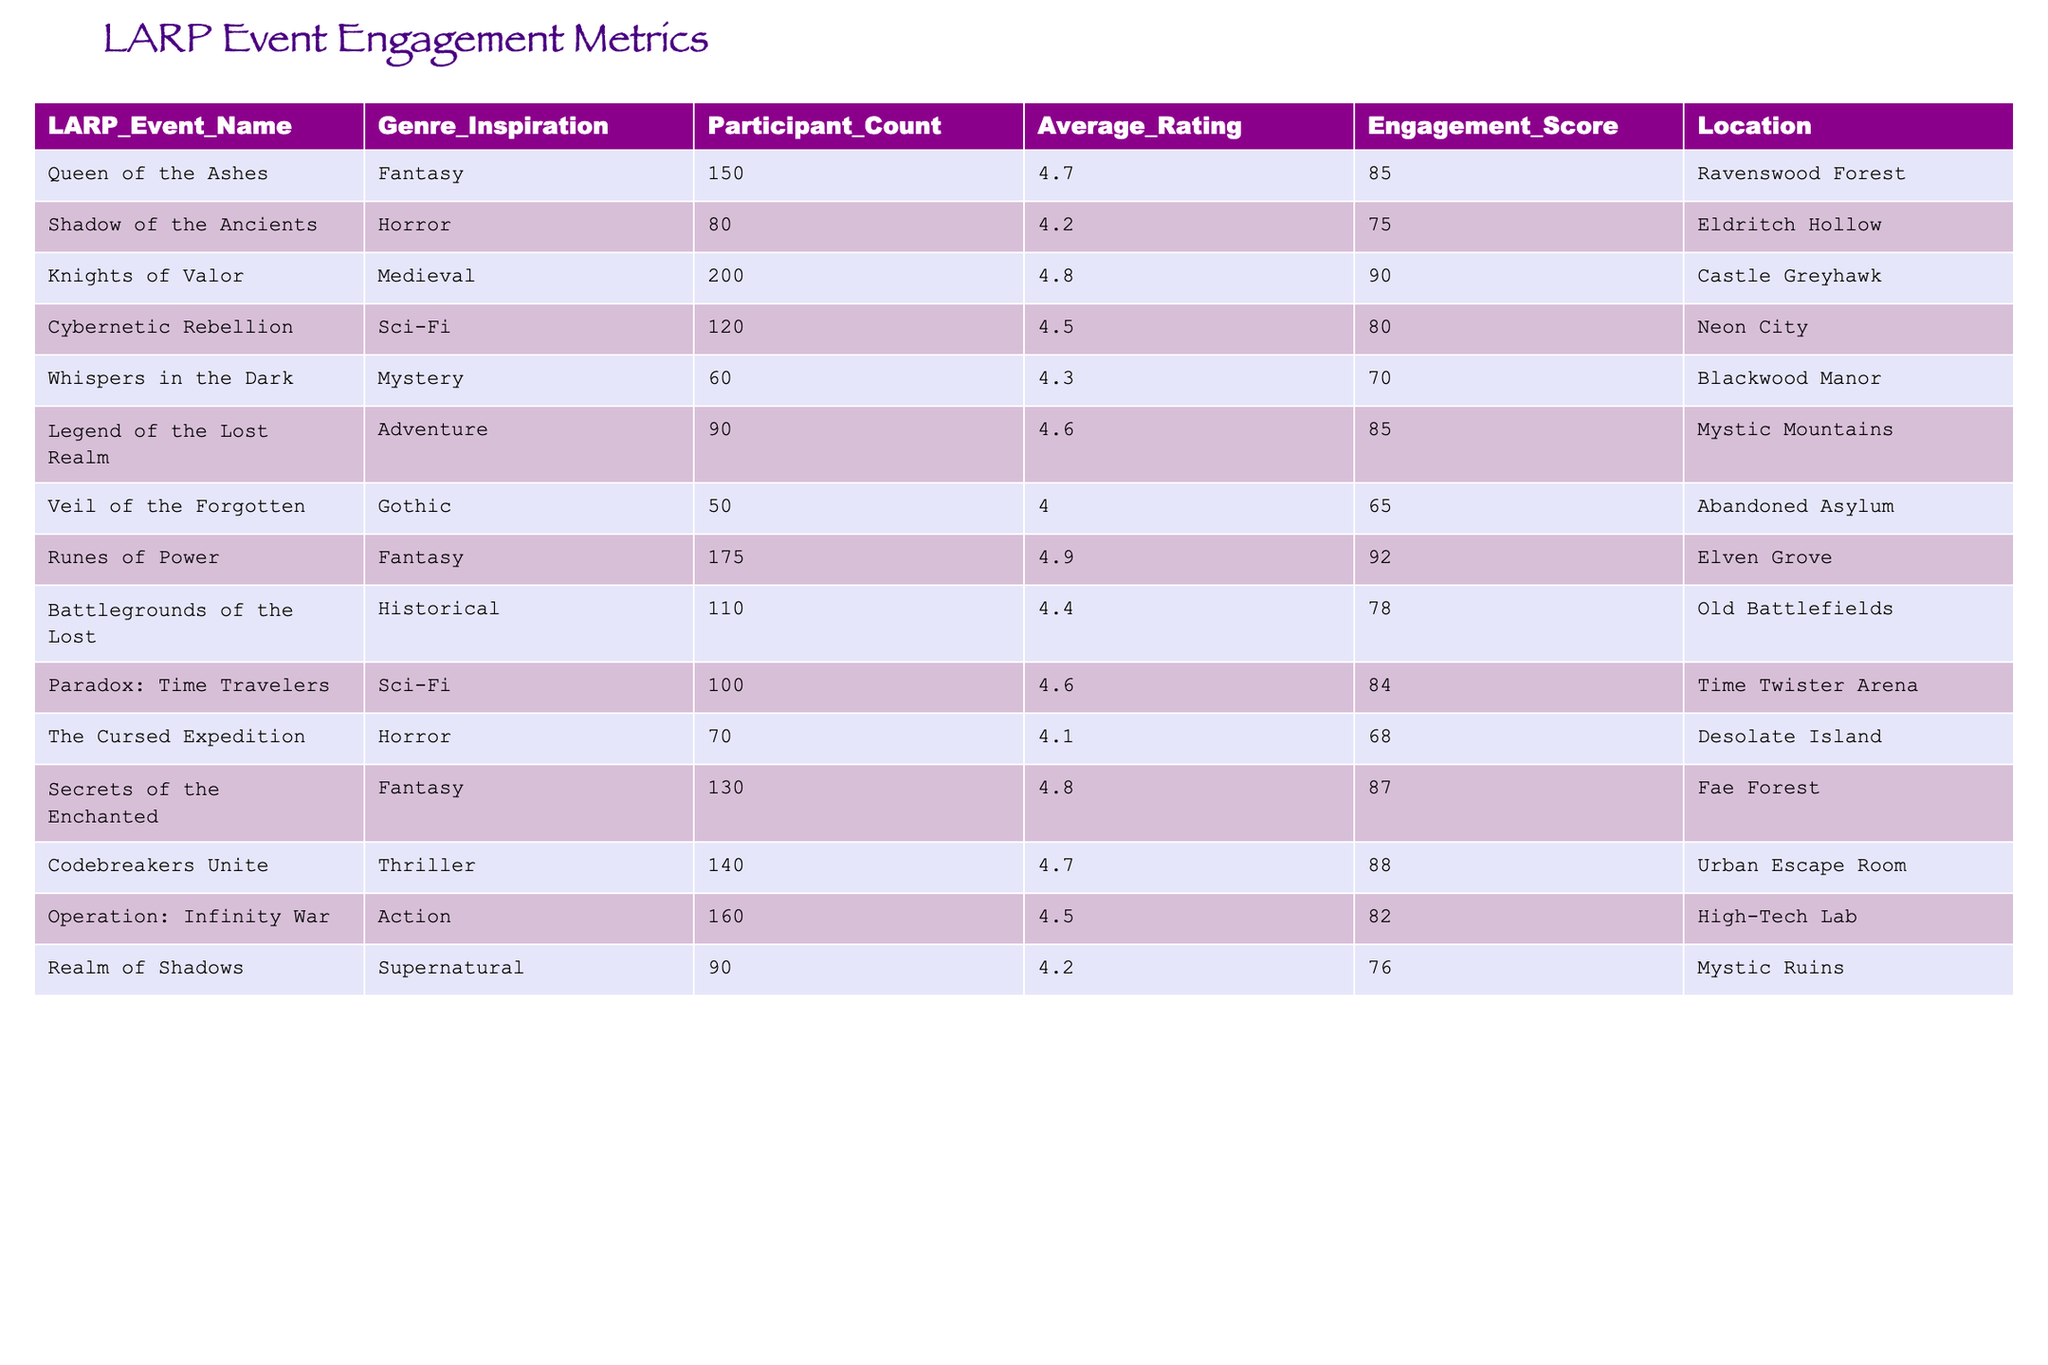What is the engagement score for the "Knights of Valor" event? The engagement score for "Knights of Valor" is listed directly in the table under the corresponding column, which shows a score of 90.
Answer: 90 What is the average participant count for the Fantasy genre events? The participant counts for the Fantasy events are 150, 175, and 130. To find the average, sum these values: 150 + 175 + 130 = 455. Then, divide by the number of events (3), which results in 455/3 = approximately 151.67.
Answer: 151.67 Which event has the highest average rating and what is that rating? Looking through the "Average_Rating" column, the highest rating is 4.9, which corresponds to the "Runes of Power" event.
Answer: 4.9 Is the "Cybernetic Rebellion" event more engaging than the "The Cursed Expedition"? The engagement score for "Cybernetic Rebellion" is 80, while "The Cursed Expedition" has an engagement score of 68. Since 80 > 68, it indicates that "Cybernetic Rebellion" is indeed more engaging.
Answer: Yes What is the total participant count across all Sci-Fi genre events? There are two Sci-Fi events: "Cybernetic Rebellion" with 120 participants and "Paradox: Time Travelers" with 100 participants. Adding these together gives 120 + 100 = 220 participants for Sci-Fi events.
Answer: 220 Which genre has the lowest average rating across its events? Upon reviewing the average ratings for each genre, Gothic has only one event ("Veil of the Forgotten") with an average rating of 4.0, which is the lowest compared to other genres.
Answer: Gothic How many participants attended events in the Horror genre altogether? The participant counts for Horror genre events are 80 ("Shadow of the Ancients") and 70 ("The Cursed Expedition"). Adding these together gives 80 + 70 = 150 participants.
Answer: 150 Which event with the highest engagement score is located in a forest? The "Runes of Power" event has the highest engagement score of 92 and is located in "Elven Grove," which is a forest.
Answer: Runes of Power What is the difference in engagement scores between the highest and lowest scoring events? The highest engagement score is 92 (from "Runes of Power") and the lowest is 65 (from "Veil of the Forgotten"). Calculating the difference gives 92 - 65 = 27.
Answer: 27 Are there more Adventure or Mystery genre events listed? There is one Adventure event ("Legend of the Lost Realm") and one Mystery event ("Whispers in the Dark"). Since both counts are equal, there are neither more Adventure nor Mystery events listed.
Answer: No 